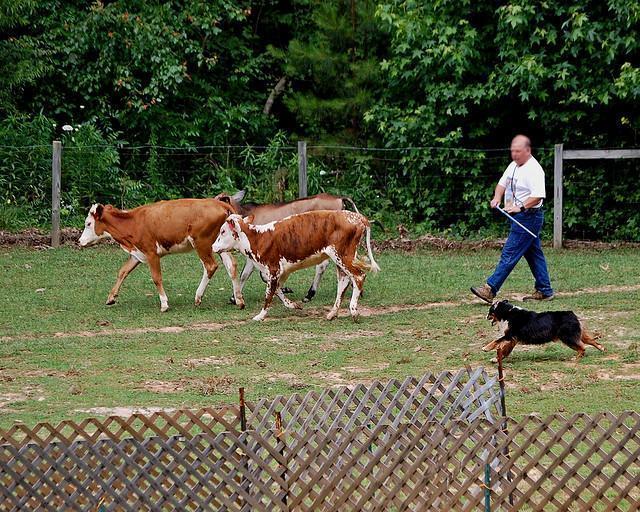How many cows are there?
Give a very brief answer. 3. How many cattle are shown in this scene?
Give a very brief answer. 3. How many dogs can you see?
Give a very brief answer. 1. How many cows can be seen?
Give a very brief answer. 3. 